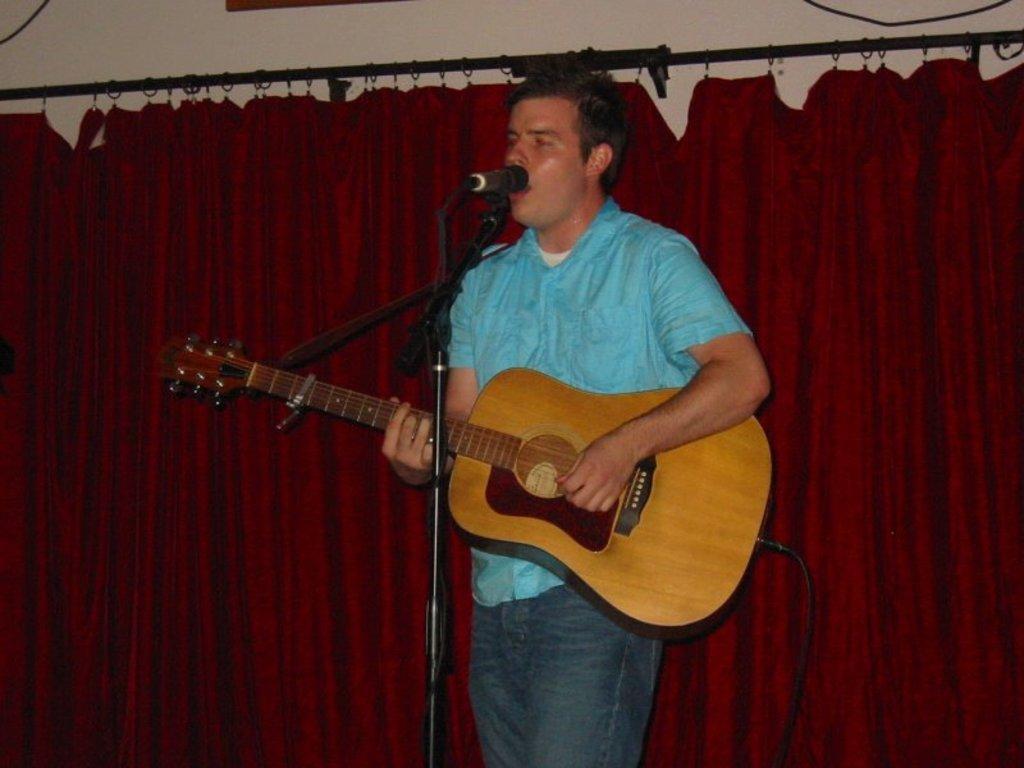Describe this image in one or two sentences. This picture is mainly highlighted with a man standing and playing a guitar in front of a mike. On the background we can see a curtain in maroon colour. 